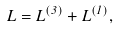Convert formula to latex. <formula><loc_0><loc_0><loc_500><loc_500>\L L = \L L ^ { ( 3 ) } + \L L ^ { ( 1 ) } ,</formula> 